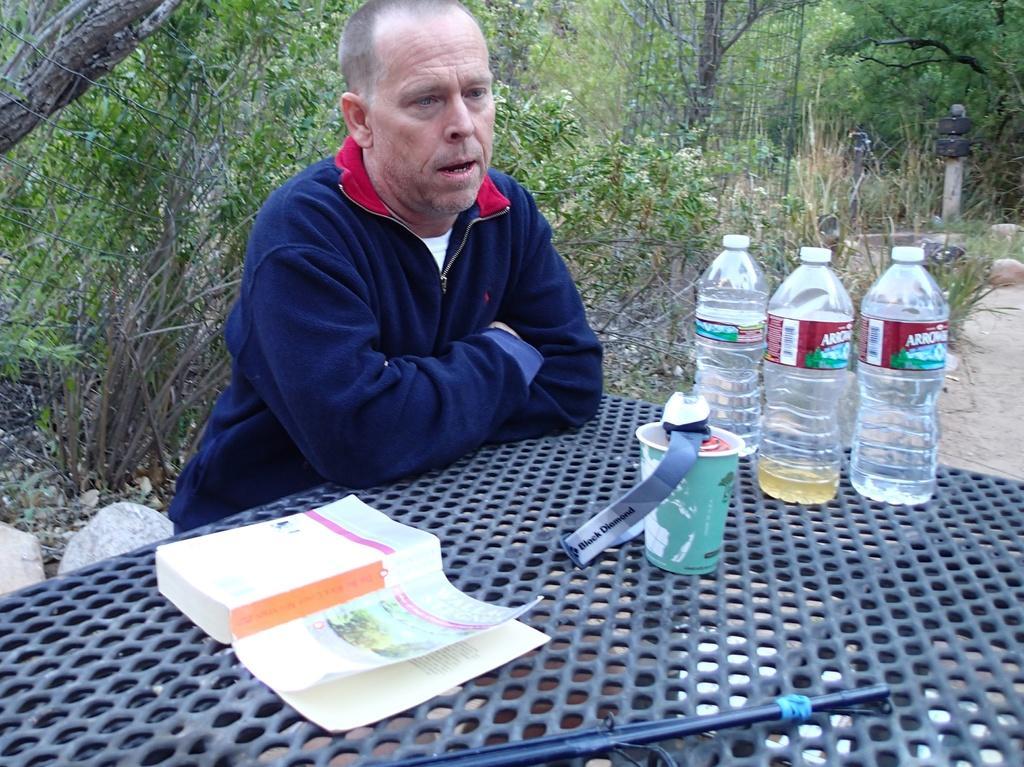How would you summarize this image in a sentence or two? Here there is a person sitting and on the table there is a book,cup,3 water bottles. In the background there are trees. 